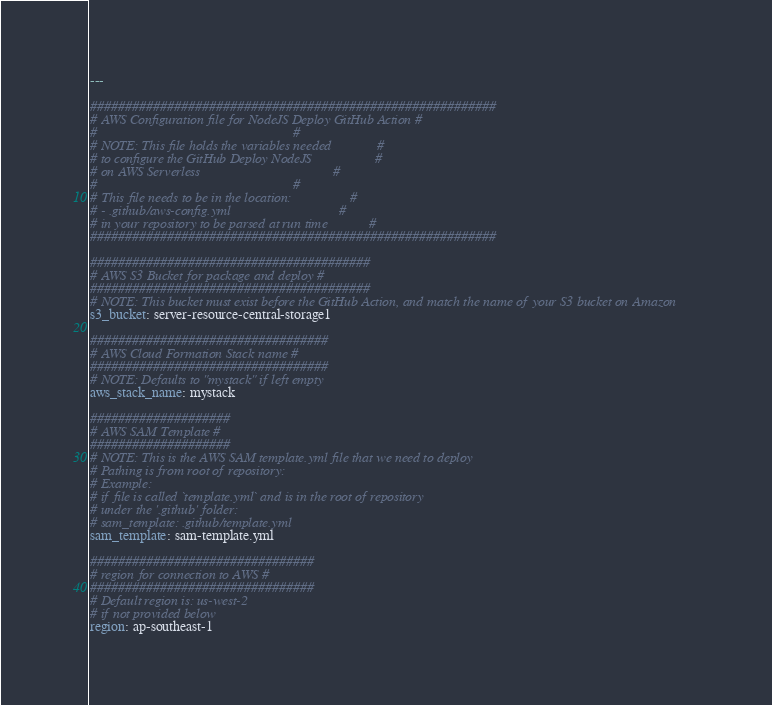<code> <loc_0><loc_0><loc_500><loc_500><_YAML_>---

##########################################################
# AWS Configuration file for NodeJS Deploy GitHub Action #
#                                                        #
# NOTE: This file holds the variables needed             #
# to configure the GitHub Deploy NodeJS                  #
# on AWS Serverless                                      #
#                                                        #
# This file needs to be in the location:                 #
# - .github/aws-config.yml                               #
# in your repository to be parsed at run time            #
##########################################################

########################################
# AWS S3 Bucket for package and deploy #
########################################
# NOTE: This bucket must exist before the GitHub Action, and match the name of your S3 bucket on Amazon
s3_bucket: server-resource-central-storage1

##################################
# AWS Cloud Formation Stack name #
##################################
# NOTE: Defaults to "mystack" if left empty
aws_stack_name: mystack

####################
# AWS SAM Template #
####################
# NOTE: This is the AWS SAM template.yml file that we need to deploy
# Pathing is from root of repository:
# Example:
# if file is called `template.yml` and is in the root of repository
# under the '.github' folder:
# sam_template: .github/template.yml
sam_template: sam-template.yml

################################
# region for connection to AWS #
################################
# Default region is: us-west-2
# if not provided below
region: ap-southeast-1
</code> 